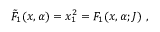Convert formula to latex. <formula><loc_0><loc_0><loc_500><loc_500>{ \tilde { F } } _ { 1 } ( x , \alpha ) = x _ { 1 } ^ { 2 } = F _ { 1 } ( x , \alpha ; J ) ,</formula> 